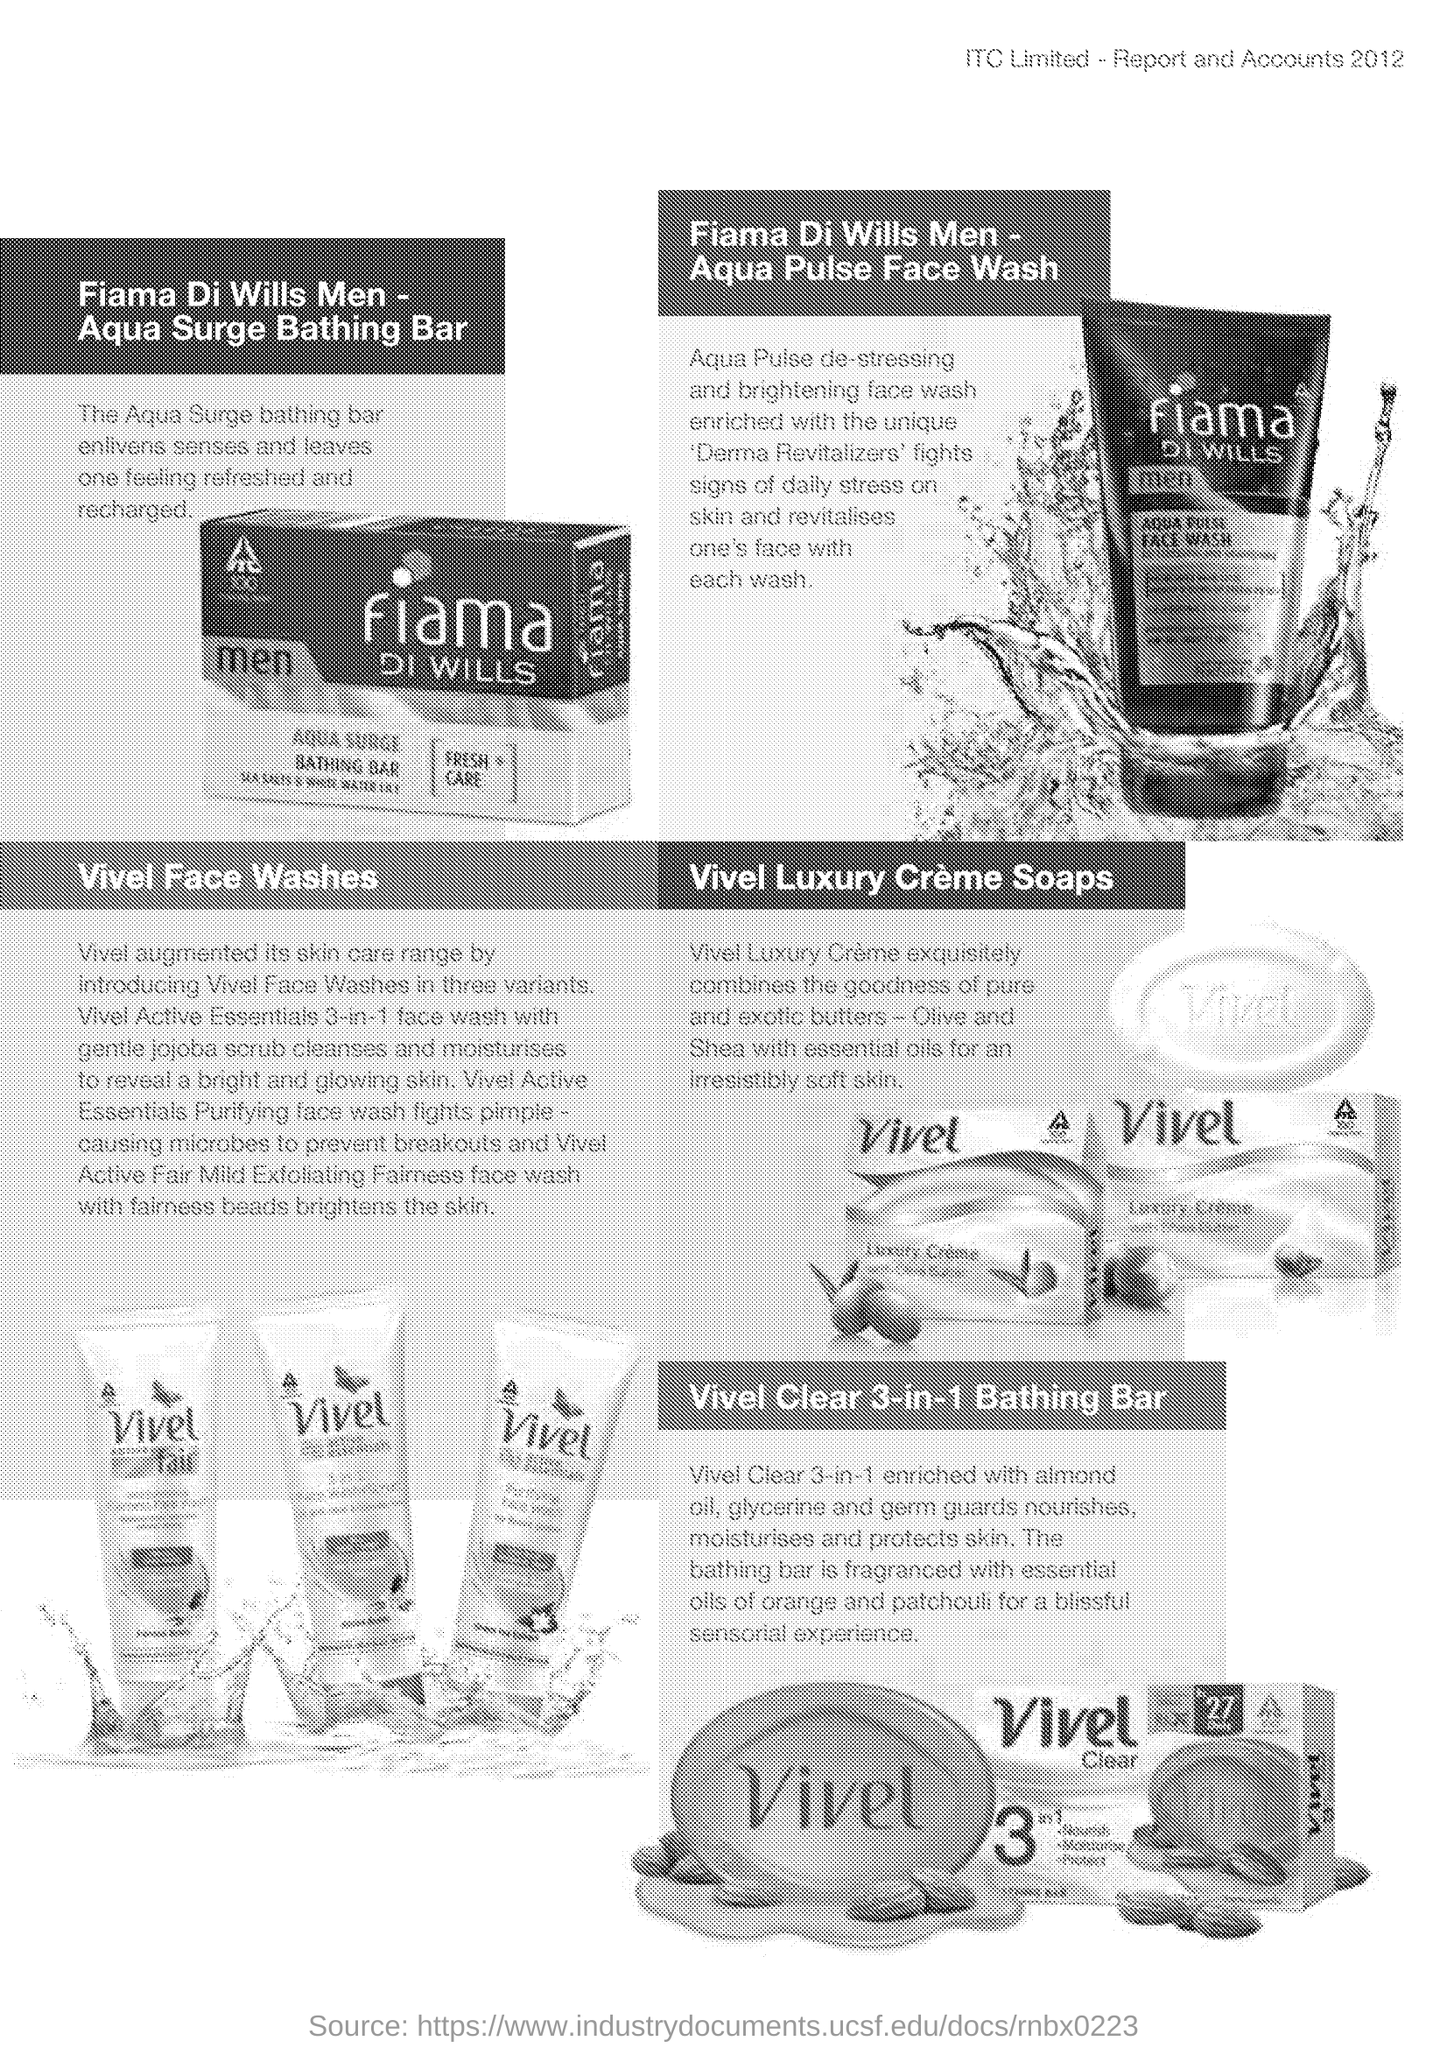"REPORTS AND ACCOUNTS" of which year is mentioned in the heading of the document?
Offer a terse response. 2012. What is written in capital letters within the company logo seen on the picture of the soap?
Ensure brevity in your answer.  ITC. Which item present in "Fiama Di Wills Men - Aqua Pulse Face Wash" fights signs of daily stress?
Offer a terse response. 'Derma Revitalizers'. "Vivel augmented its skin care range by introducing vivel Face Washes" in how many variants?
Your answer should be very brief. Three. Vivel Clear 3-in-1 Bathing Bar is frangranced with which "essential oils"?
Your answer should be compact. Essential oils of orange and patchouli. 